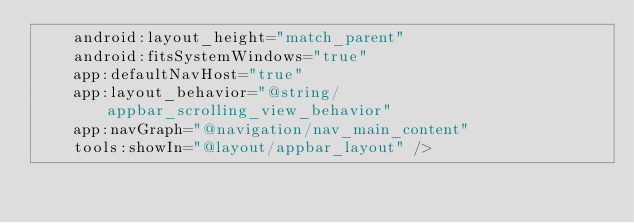Convert code to text. <code><loc_0><loc_0><loc_500><loc_500><_XML_>    android:layout_height="match_parent"
    android:fitsSystemWindows="true"
    app:defaultNavHost="true"
    app:layout_behavior="@string/appbar_scrolling_view_behavior"
    app:navGraph="@navigation/nav_main_content"
    tools:showIn="@layout/appbar_layout" /></code> 